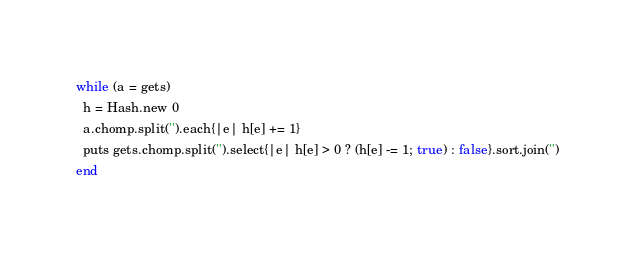Convert code to text. <code><loc_0><loc_0><loc_500><loc_500><_Ruby_>while (a = gets)
  h = Hash.new 0
  a.chomp.split('').each{|e| h[e] += 1}
  puts gets.chomp.split('').select{|e| h[e] > 0 ? (h[e] -= 1; true) : false}.sort.join('')
end
</code> 